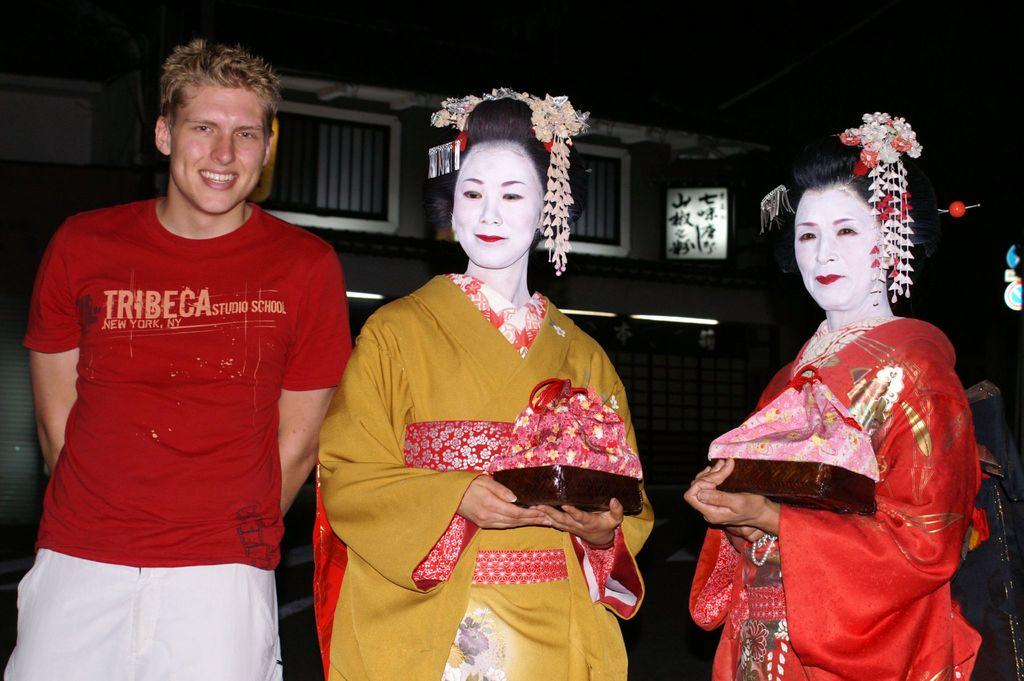<image>
Offer a succinct explanation of the picture presented. A man in a red Tribeca shirt stand next to two women dressed in kabuki. 